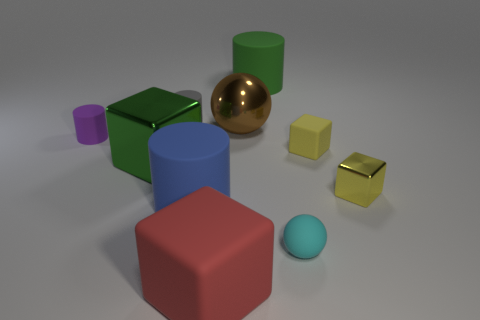Subtract all big blue rubber cylinders. How many cylinders are left? 3 Subtract all blue cylinders. How many yellow blocks are left? 2 Subtract all blue cylinders. How many cylinders are left? 3 Subtract 2 cylinders. How many cylinders are left? 2 Subtract all balls. How many objects are left? 8 Add 5 rubber cylinders. How many rubber cylinders exist? 9 Subtract 0 red balls. How many objects are left? 10 Subtract all gray cubes. Subtract all red balls. How many cubes are left? 4 Subtract all big metallic cubes. Subtract all brown metal balls. How many objects are left? 8 Add 4 large green objects. How many large green objects are left? 6 